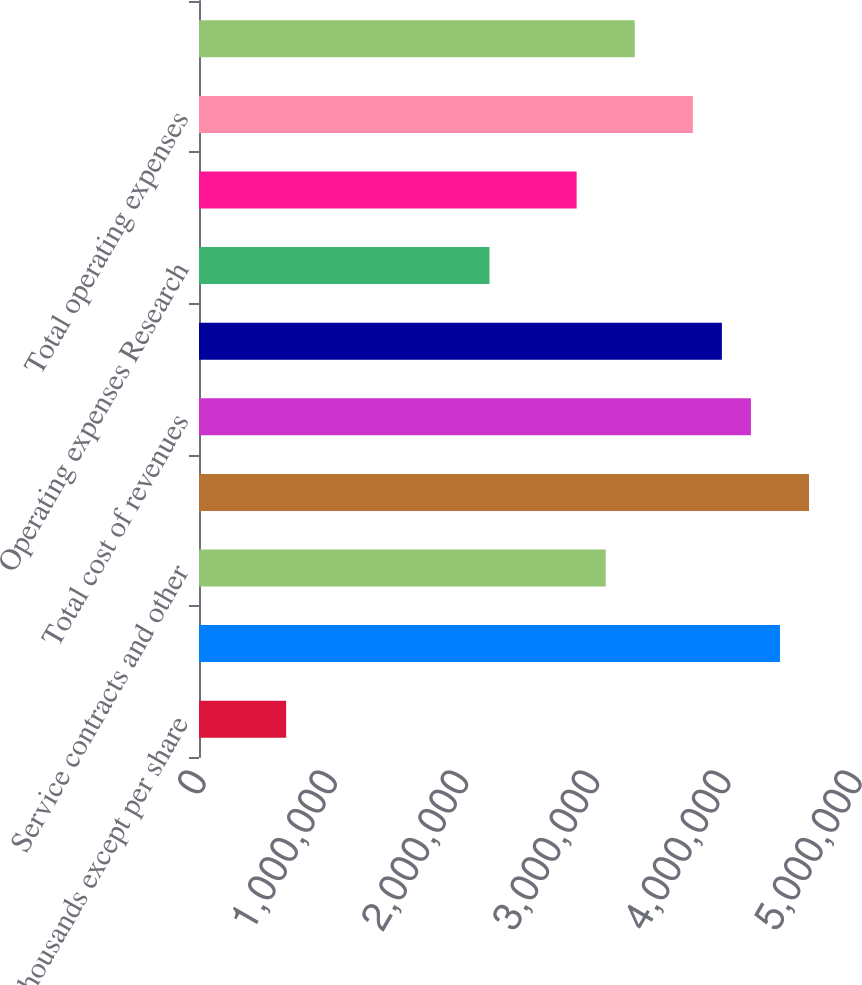<chart> <loc_0><loc_0><loc_500><loc_500><bar_chart><fcel>(In thousands except per share<fcel>Product<fcel>Service contracts and other<fcel>Total revenues<fcel>Total cost of revenues<fcel>Gross margin<fcel>Operating expenses Research<fcel>Selling general and<fcel>Total operating expenses<fcel>Operating earnings<nl><fcel>664218<fcel>4.42812e+06<fcel>3.09968e+06<fcel>4.64953e+06<fcel>4.20671e+06<fcel>3.98531e+06<fcel>2.21406e+06<fcel>2.87828e+06<fcel>3.7639e+06<fcel>3.32109e+06<nl></chart> 